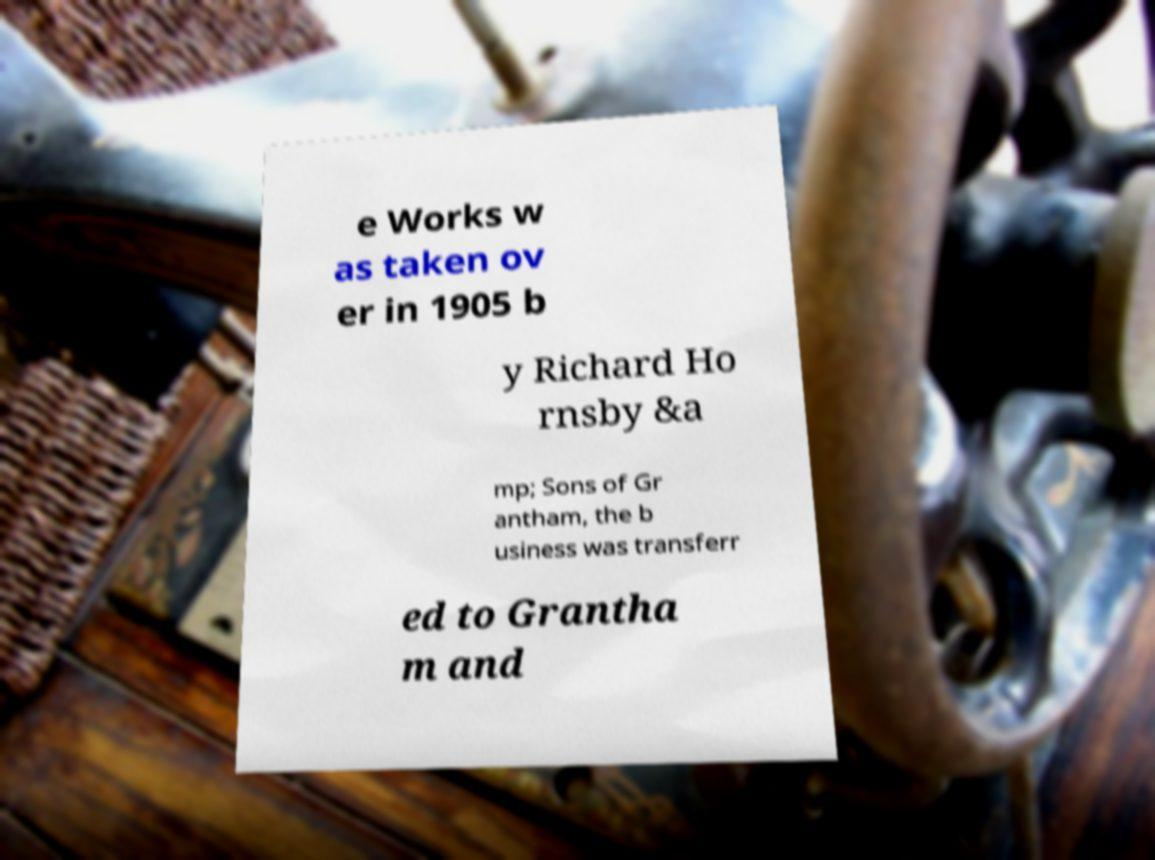There's text embedded in this image that I need extracted. Can you transcribe it verbatim? e Works w as taken ov er in 1905 b y Richard Ho rnsby &a mp; Sons of Gr antham, the b usiness was transferr ed to Grantha m and 